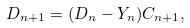<formula> <loc_0><loc_0><loc_500><loc_500>D _ { n + 1 } = ( D _ { n } - Y _ { n } ) C _ { n + 1 } ,</formula> 